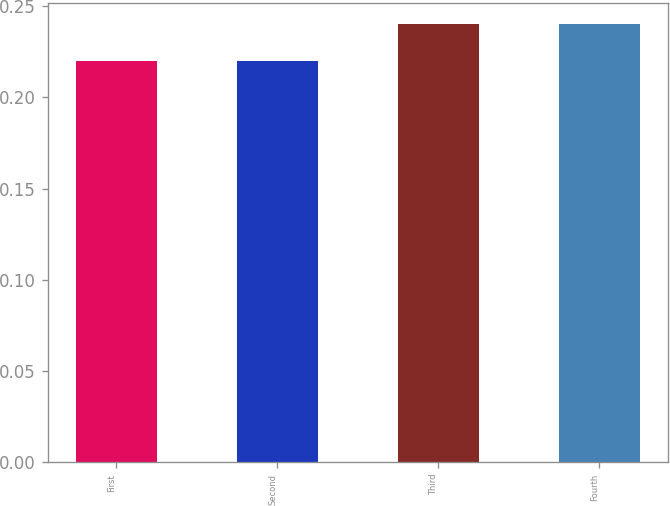<chart> <loc_0><loc_0><loc_500><loc_500><bar_chart><fcel>First<fcel>Second<fcel>Third<fcel>Fourth<nl><fcel>0.22<fcel>0.22<fcel>0.24<fcel>0.24<nl></chart> 